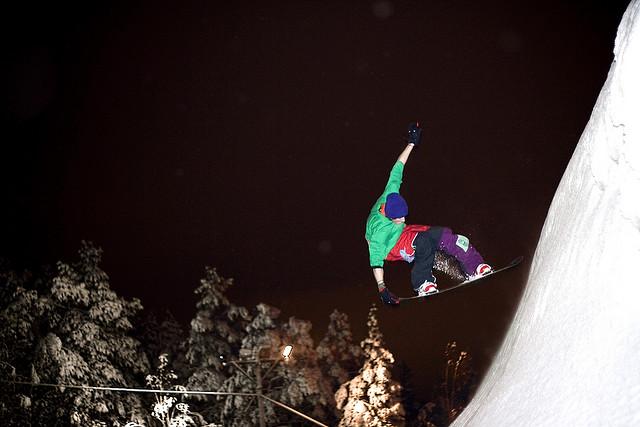What color is the man's hat?
Answer briefly. Blue. Is the man skiing?
Keep it brief. No. Is he holding the snowboard?
Be succinct. Yes. 